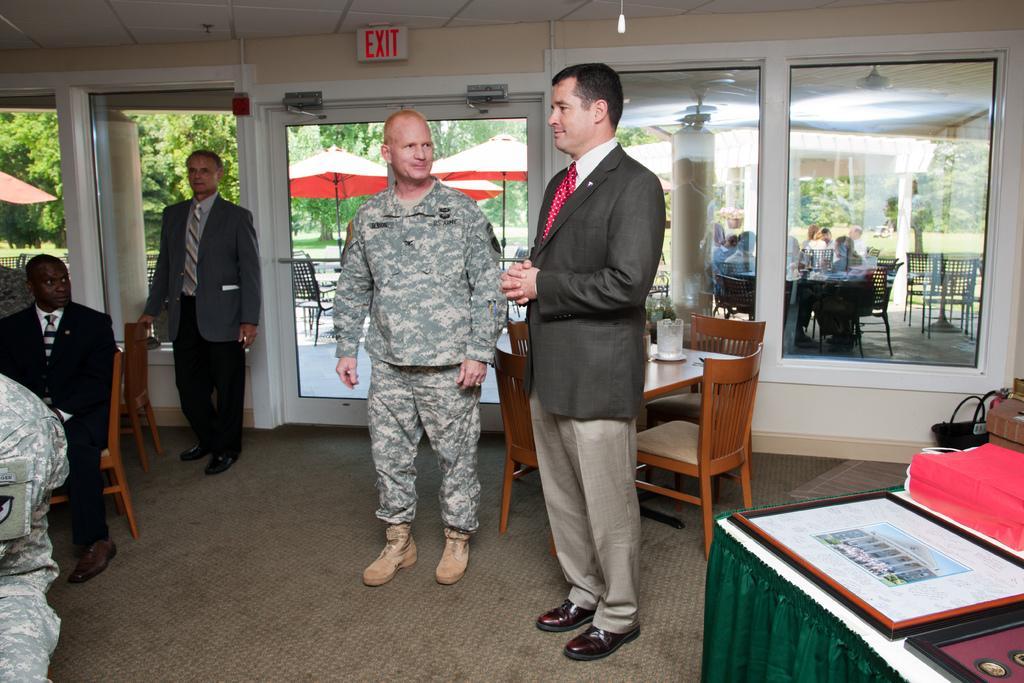Describe this image in one or two sentences. In this image I see 4 men, in which 3 of them are standing and one of them is sitting. In the background I see the chairs, tables and few people over here and the trees. 